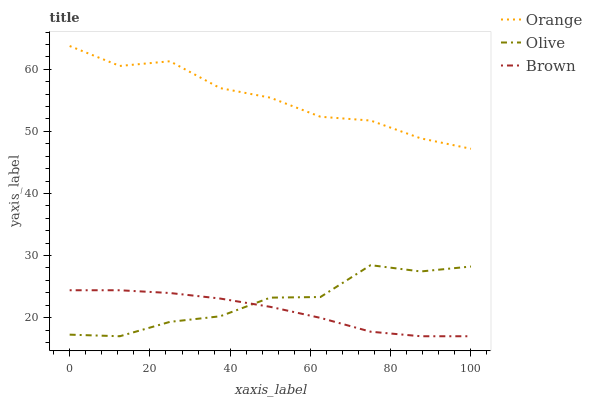Does Brown have the minimum area under the curve?
Answer yes or no. Yes. Does Orange have the maximum area under the curve?
Answer yes or no. Yes. Does Olive have the minimum area under the curve?
Answer yes or no. No. Does Olive have the maximum area under the curve?
Answer yes or no. No. Is Brown the smoothest?
Answer yes or no. Yes. Is Olive the roughest?
Answer yes or no. Yes. Is Olive the smoothest?
Answer yes or no. No. Is Brown the roughest?
Answer yes or no. No. Does Olive have the lowest value?
Answer yes or no. Yes. Does Orange have the highest value?
Answer yes or no. Yes. Does Olive have the highest value?
Answer yes or no. No. Is Brown less than Orange?
Answer yes or no. Yes. Is Orange greater than Brown?
Answer yes or no. Yes. Does Brown intersect Olive?
Answer yes or no. Yes. Is Brown less than Olive?
Answer yes or no. No. Is Brown greater than Olive?
Answer yes or no. No. Does Brown intersect Orange?
Answer yes or no. No. 